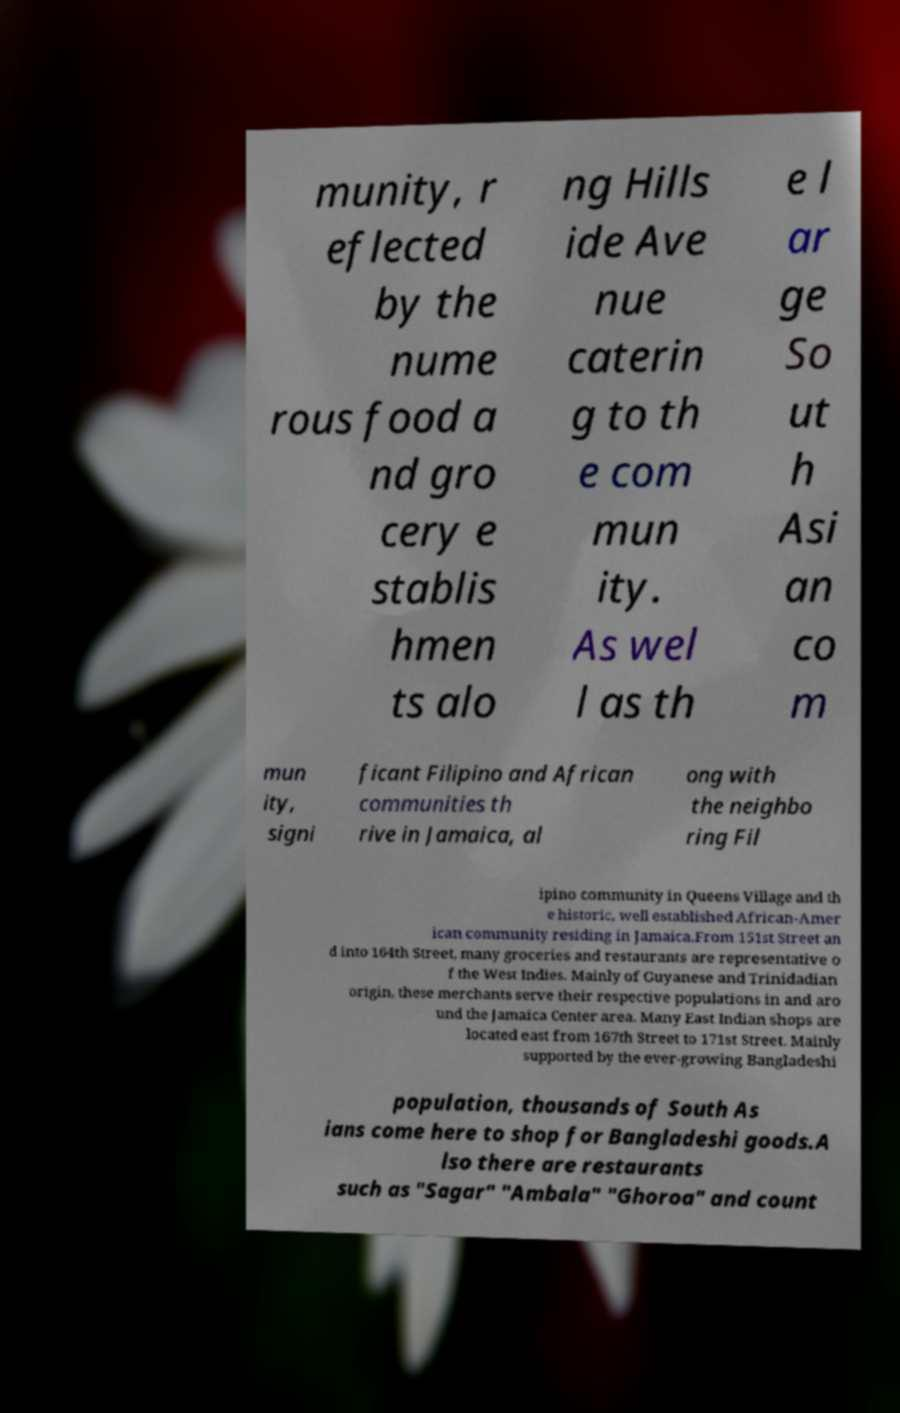There's text embedded in this image that I need extracted. Can you transcribe it verbatim? munity, r eflected by the nume rous food a nd gro cery e stablis hmen ts alo ng Hills ide Ave nue caterin g to th e com mun ity. As wel l as th e l ar ge So ut h Asi an co m mun ity, signi ficant Filipino and African communities th rive in Jamaica, al ong with the neighbo ring Fil ipino community in Queens Village and th e historic, well established African-Amer ican community residing in Jamaica.From 151st Street an d into 164th Street, many groceries and restaurants are representative o f the West Indies. Mainly of Guyanese and Trinidadian origin, these merchants serve their respective populations in and aro und the Jamaica Center area. Many East Indian shops are located east from 167th Street to 171st Street. Mainly supported by the ever-growing Bangladeshi population, thousands of South As ians come here to shop for Bangladeshi goods.A lso there are restaurants such as "Sagar" "Ambala" "Ghoroa" and count 